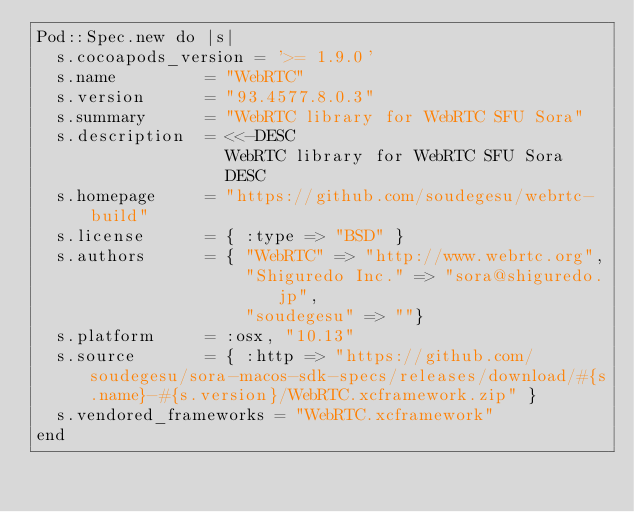<code> <loc_0><loc_0><loc_500><loc_500><_Ruby_>Pod::Spec.new do |s|
  s.cocoapods_version = '>= 1.9.0'
  s.name         = "WebRTC"
  s.version      = "93.4577.8.0.3"
  s.summary      = "WebRTC library for WebRTC SFU Sora"
  s.description  = <<-DESC
                   WebRTC library for WebRTC SFU Sora
                   DESC
  s.homepage     = "https://github.com/soudegesu/webrtc-build"
  s.license      = { :type => "BSD" }
  s.authors      = { "WebRTC" => "http://www.webrtc.org",
                     "Shiguredo Inc." => "sora@shiguredo.jp",
                     "soudegesu" => ""}
  s.platform     = :osx, "10.13"
  s.source       = { :http => "https://github.com/soudegesu/sora-macos-sdk-specs/releases/download/#{s.name}-#{s.version}/WebRTC.xcframework.zip" }
  s.vendored_frameworks = "WebRTC.xcframework"
end
</code> 